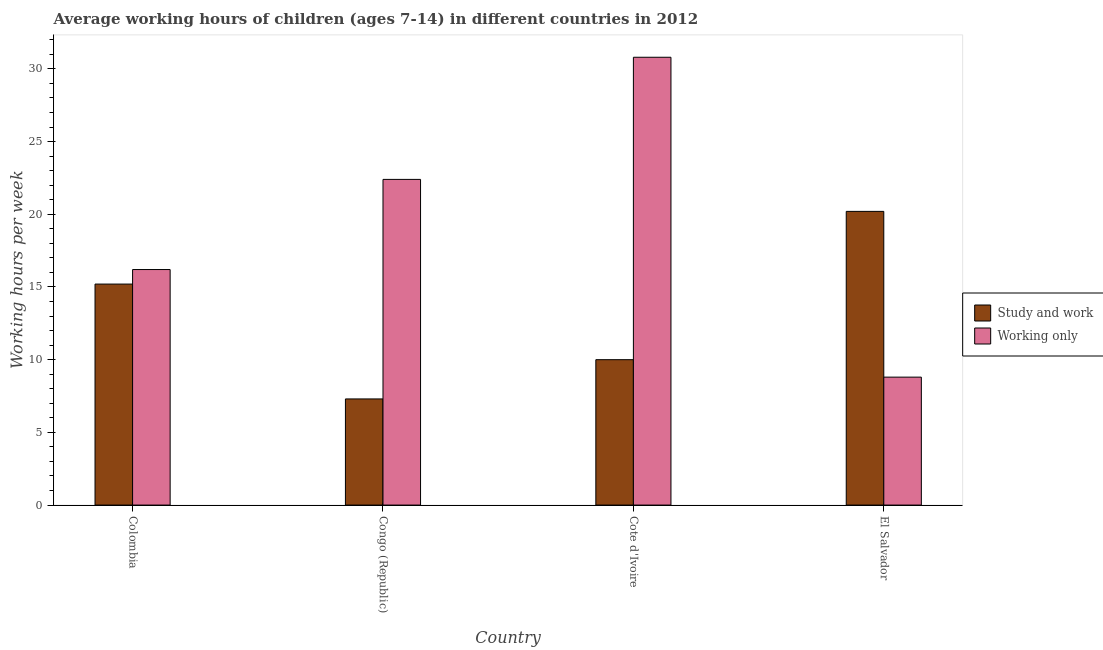How many groups of bars are there?
Keep it short and to the point. 4. Are the number of bars per tick equal to the number of legend labels?
Provide a succinct answer. Yes. How many bars are there on the 1st tick from the right?
Keep it short and to the point. 2. What is the label of the 4th group of bars from the left?
Give a very brief answer. El Salvador. In how many cases, is the number of bars for a given country not equal to the number of legend labels?
Your answer should be compact. 0. Across all countries, what is the maximum average working hour of children involved in study and work?
Provide a succinct answer. 20.2. Across all countries, what is the minimum average working hour of children involved in only work?
Offer a very short reply. 8.8. In which country was the average working hour of children involved in only work maximum?
Your response must be concise. Cote d'Ivoire. In which country was the average working hour of children involved in only work minimum?
Provide a succinct answer. El Salvador. What is the total average working hour of children involved in only work in the graph?
Give a very brief answer. 78.2. What is the difference between the average working hour of children involved in study and work in Colombia and that in Cote d'Ivoire?
Keep it short and to the point. 5.2. What is the difference between the average working hour of children involved in study and work in El Salvador and the average working hour of children involved in only work in Cote d'Ivoire?
Provide a succinct answer. -10.6. What is the average average working hour of children involved in only work per country?
Your answer should be compact. 19.55. What is the difference between the average working hour of children involved in study and work and average working hour of children involved in only work in Cote d'Ivoire?
Provide a short and direct response. -20.8. In how many countries, is the average working hour of children involved in only work greater than 6 hours?
Your response must be concise. 4. What is the ratio of the average working hour of children involved in study and work in Congo (Republic) to that in Cote d'Ivoire?
Your response must be concise. 0.73. What is the difference between the highest and the lowest average working hour of children involved in study and work?
Your response must be concise. 12.9. What does the 2nd bar from the left in Congo (Republic) represents?
Give a very brief answer. Working only. What does the 2nd bar from the right in Colombia represents?
Provide a succinct answer. Study and work. Are all the bars in the graph horizontal?
Give a very brief answer. No. What is the difference between two consecutive major ticks on the Y-axis?
Offer a very short reply. 5. Are the values on the major ticks of Y-axis written in scientific E-notation?
Offer a very short reply. No. Does the graph contain grids?
Your answer should be very brief. No. How are the legend labels stacked?
Make the answer very short. Vertical. What is the title of the graph?
Your answer should be very brief. Average working hours of children (ages 7-14) in different countries in 2012. Does "Resident" appear as one of the legend labels in the graph?
Your response must be concise. No. What is the label or title of the X-axis?
Your answer should be compact. Country. What is the label or title of the Y-axis?
Your response must be concise. Working hours per week. What is the Working hours per week of Working only in Congo (Republic)?
Keep it short and to the point. 22.4. What is the Working hours per week of Study and work in Cote d'Ivoire?
Your answer should be compact. 10. What is the Working hours per week of Working only in Cote d'Ivoire?
Offer a terse response. 30.8. What is the Working hours per week in Study and work in El Salvador?
Your answer should be compact. 20.2. What is the Working hours per week of Working only in El Salvador?
Give a very brief answer. 8.8. Across all countries, what is the maximum Working hours per week of Study and work?
Provide a succinct answer. 20.2. Across all countries, what is the maximum Working hours per week of Working only?
Provide a succinct answer. 30.8. Across all countries, what is the minimum Working hours per week of Study and work?
Make the answer very short. 7.3. Across all countries, what is the minimum Working hours per week in Working only?
Ensure brevity in your answer.  8.8. What is the total Working hours per week of Study and work in the graph?
Offer a terse response. 52.7. What is the total Working hours per week in Working only in the graph?
Offer a terse response. 78.2. What is the difference between the Working hours per week in Study and work in Colombia and that in Cote d'Ivoire?
Your answer should be very brief. 5.2. What is the difference between the Working hours per week in Working only in Colombia and that in Cote d'Ivoire?
Offer a very short reply. -14.6. What is the difference between the Working hours per week of Working only in Congo (Republic) and that in Cote d'Ivoire?
Your answer should be very brief. -8.4. What is the difference between the Working hours per week of Study and work in Congo (Republic) and that in El Salvador?
Give a very brief answer. -12.9. What is the difference between the Working hours per week in Working only in Congo (Republic) and that in El Salvador?
Give a very brief answer. 13.6. What is the difference between the Working hours per week of Study and work in Cote d'Ivoire and that in El Salvador?
Your response must be concise. -10.2. What is the difference between the Working hours per week in Study and work in Colombia and the Working hours per week in Working only in Congo (Republic)?
Offer a very short reply. -7.2. What is the difference between the Working hours per week of Study and work in Colombia and the Working hours per week of Working only in Cote d'Ivoire?
Your answer should be compact. -15.6. What is the difference between the Working hours per week of Study and work in Colombia and the Working hours per week of Working only in El Salvador?
Your answer should be compact. 6.4. What is the difference between the Working hours per week in Study and work in Congo (Republic) and the Working hours per week in Working only in Cote d'Ivoire?
Your response must be concise. -23.5. What is the difference between the Working hours per week of Study and work in Congo (Republic) and the Working hours per week of Working only in El Salvador?
Offer a very short reply. -1.5. What is the average Working hours per week of Study and work per country?
Your response must be concise. 13.18. What is the average Working hours per week of Working only per country?
Give a very brief answer. 19.55. What is the difference between the Working hours per week in Study and work and Working hours per week in Working only in Colombia?
Provide a succinct answer. -1. What is the difference between the Working hours per week of Study and work and Working hours per week of Working only in Congo (Republic)?
Ensure brevity in your answer.  -15.1. What is the difference between the Working hours per week in Study and work and Working hours per week in Working only in Cote d'Ivoire?
Give a very brief answer. -20.8. What is the ratio of the Working hours per week in Study and work in Colombia to that in Congo (Republic)?
Offer a very short reply. 2.08. What is the ratio of the Working hours per week of Working only in Colombia to that in Congo (Republic)?
Your answer should be compact. 0.72. What is the ratio of the Working hours per week of Study and work in Colombia to that in Cote d'Ivoire?
Keep it short and to the point. 1.52. What is the ratio of the Working hours per week of Working only in Colombia to that in Cote d'Ivoire?
Make the answer very short. 0.53. What is the ratio of the Working hours per week in Study and work in Colombia to that in El Salvador?
Make the answer very short. 0.75. What is the ratio of the Working hours per week of Working only in Colombia to that in El Salvador?
Your answer should be compact. 1.84. What is the ratio of the Working hours per week of Study and work in Congo (Republic) to that in Cote d'Ivoire?
Give a very brief answer. 0.73. What is the ratio of the Working hours per week in Working only in Congo (Republic) to that in Cote d'Ivoire?
Keep it short and to the point. 0.73. What is the ratio of the Working hours per week in Study and work in Congo (Republic) to that in El Salvador?
Make the answer very short. 0.36. What is the ratio of the Working hours per week in Working only in Congo (Republic) to that in El Salvador?
Ensure brevity in your answer.  2.55. What is the ratio of the Working hours per week of Study and work in Cote d'Ivoire to that in El Salvador?
Provide a short and direct response. 0.49. What is the ratio of the Working hours per week in Working only in Cote d'Ivoire to that in El Salvador?
Make the answer very short. 3.5. What is the difference between the highest and the second highest Working hours per week of Study and work?
Offer a very short reply. 5. What is the difference between the highest and the lowest Working hours per week in Study and work?
Your answer should be compact. 12.9. What is the difference between the highest and the lowest Working hours per week in Working only?
Your response must be concise. 22. 